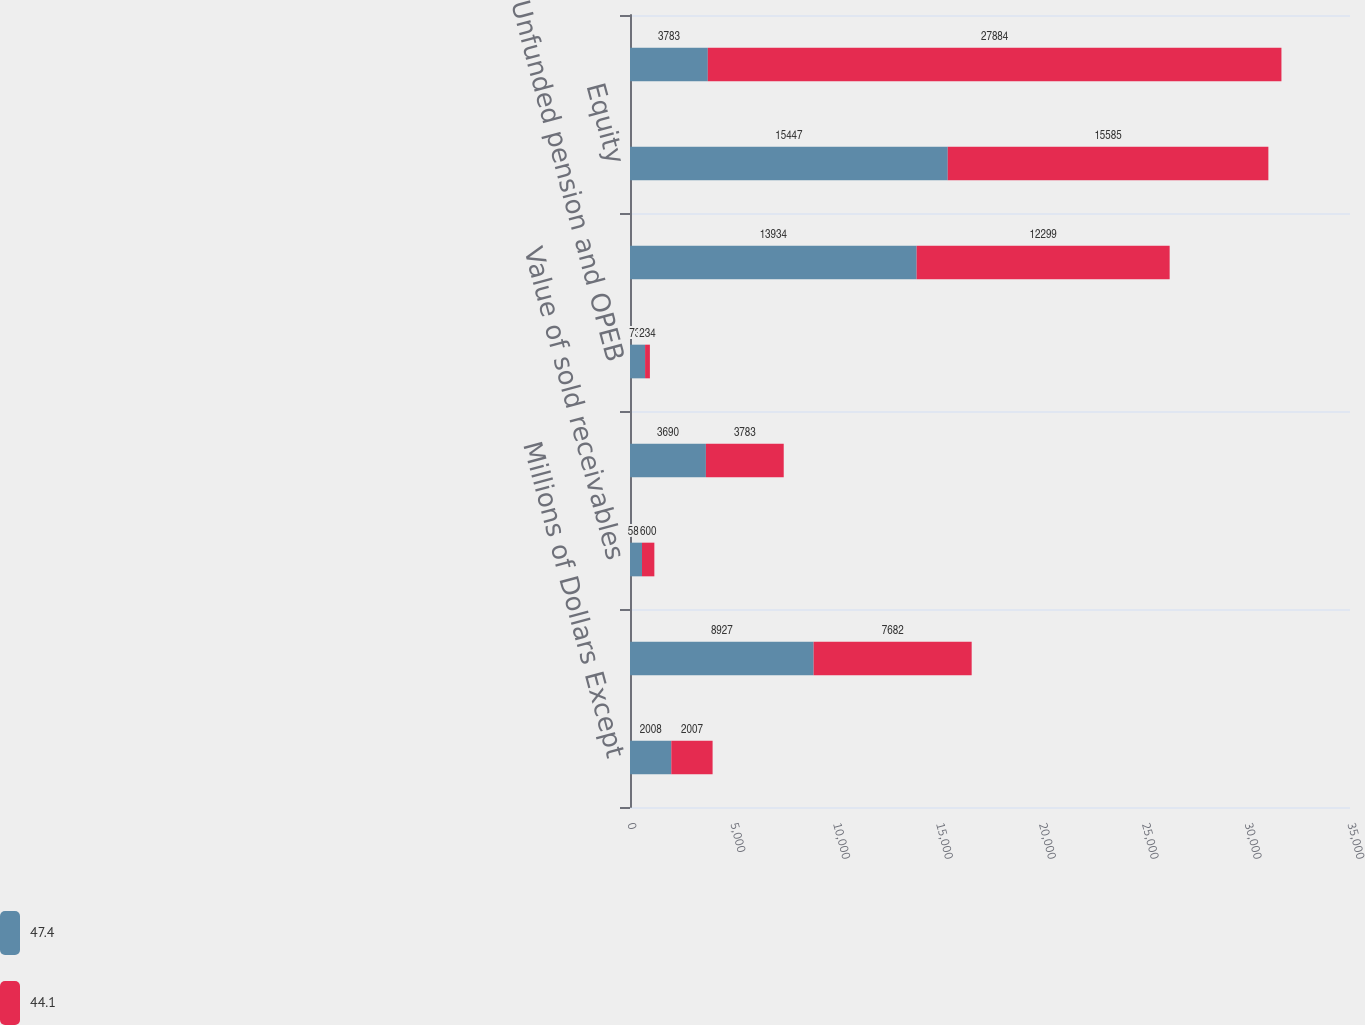<chart> <loc_0><loc_0><loc_500><loc_500><stacked_bar_chart><ecel><fcel>Millions of Dollars Except<fcel>Debt<fcel>Value of sold receivables<fcel>Net present value of operating<fcel>Unfunded pension and OPEB<fcel>Adjusted debt (a)<fcel>Equity<fcel>Adjusted capital (b)<nl><fcel>47.4<fcel>2008<fcel>8927<fcel>584<fcel>3690<fcel>733<fcel>13934<fcel>15447<fcel>3783<nl><fcel>44.1<fcel>2007<fcel>7682<fcel>600<fcel>3783<fcel>234<fcel>12299<fcel>15585<fcel>27884<nl></chart> 